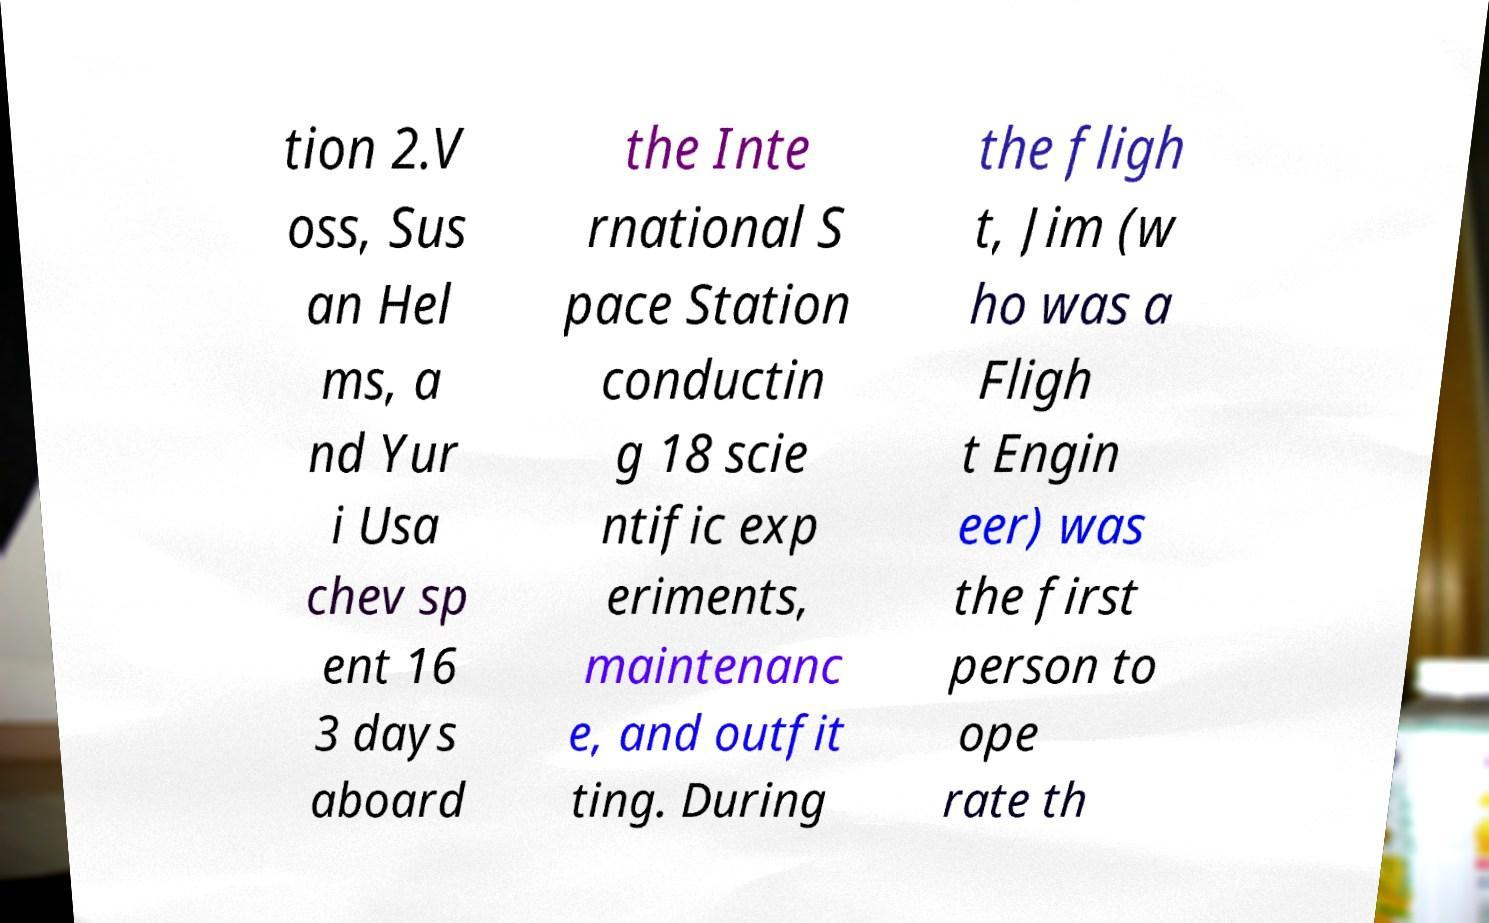Please identify and transcribe the text found in this image. tion 2.V oss, Sus an Hel ms, a nd Yur i Usa chev sp ent 16 3 days aboard the Inte rnational S pace Station conductin g 18 scie ntific exp eriments, maintenanc e, and outfit ting. During the fligh t, Jim (w ho was a Fligh t Engin eer) was the first person to ope rate th 